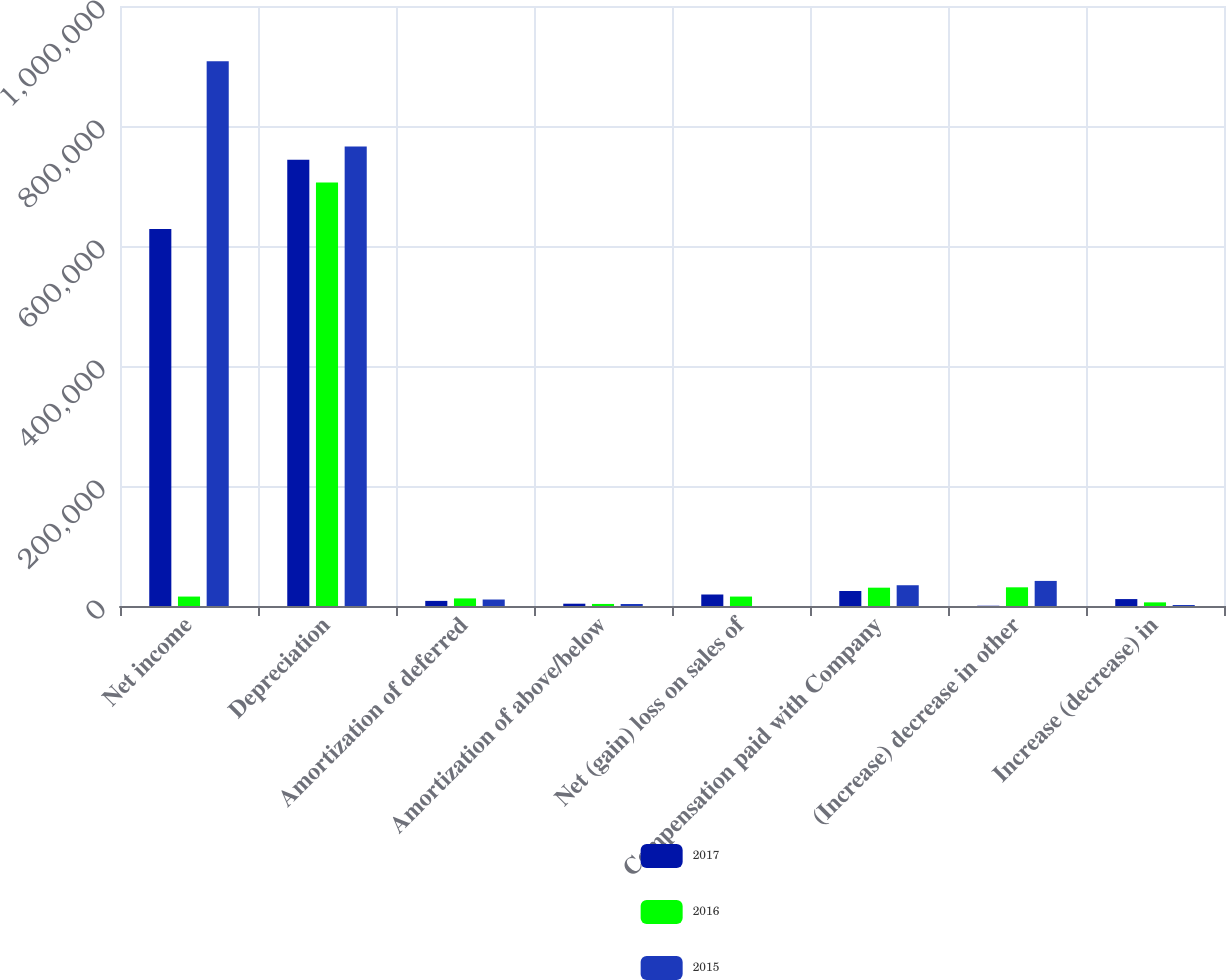Convert chart. <chart><loc_0><loc_0><loc_500><loc_500><stacked_bar_chart><ecel><fcel>Net income<fcel>Depreciation<fcel>Amortization of deferred<fcel>Amortization of above/below<fcel>Net (gain) loss on sales of<fcel>Compensation paid with Company<fcel>(Increase) decrease in other<fcel>Increase (decrease) in<nl><fcel>2017<fcel>628381<fcel>743749<fcel>8526<fcel>3828<fcel>19167<fcel>24997<fcel>449<fcel>11532<nl><fcel>2016<fcel>15731<fcel>705649<fcel>12633<fcel>3426<fcel>15731<fcel>30530<fcel>31147<fcel>6061<nl><fcel>2015<fcel>908018<fcel>765895<fcel>10801<fcel>3382<fcel>1<fcel>34607<fcel>41803<fcel>1667<nl></chart> 